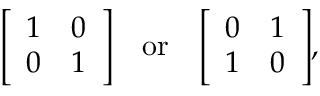<formula> <loc_0><loc_0><loc_500><loc_500>{ \left [ \begin{array} { l l } { 1 } & { 0 } \\ { 0 } & { 1 } \end{array} \right ] } \quad o r \quad \left [ \begin{array} { l l } { 0 } & { 1 } \\ { 1 } & { 0 } \end{array} \right ] ,</formula> 